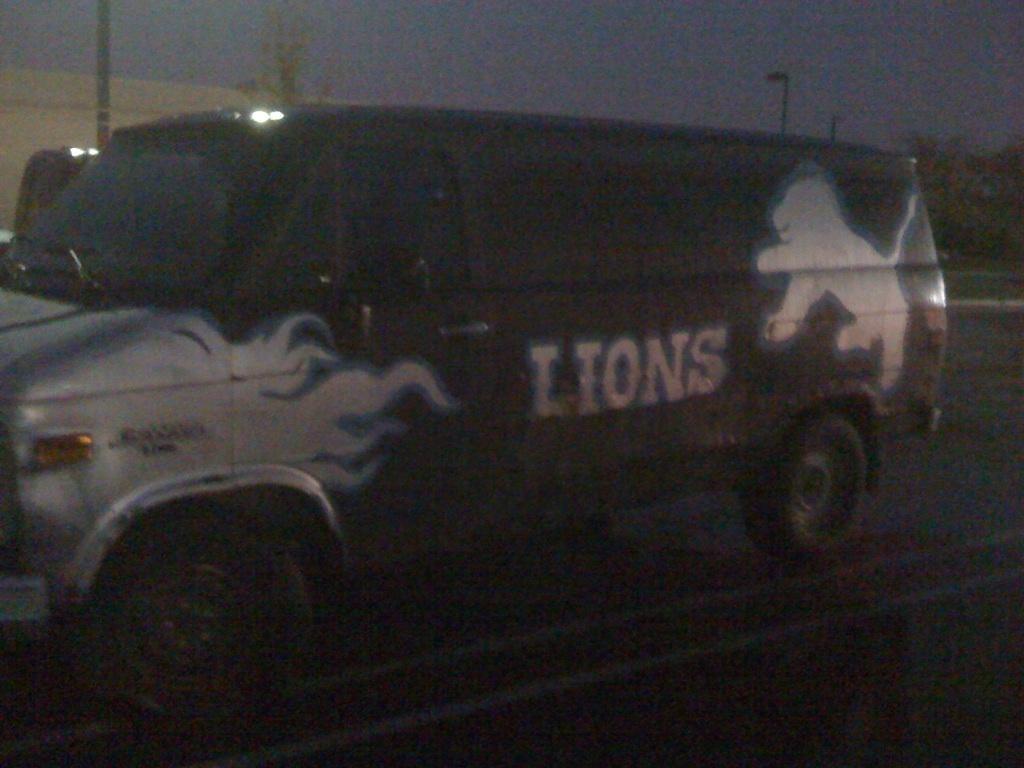In one or two sentences, can you explain what this image depicts? This is an image clicked in the dark. Here I can see a vehicle on the road. In the background there are few light poles. At the top of the image I can see the sky. 